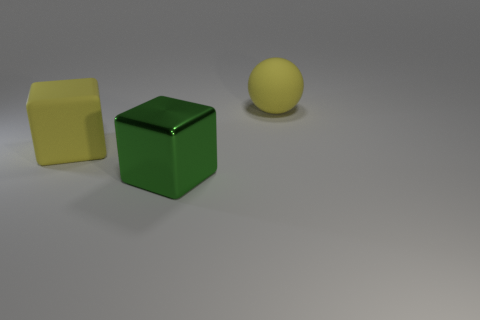What is the large yellow thing behind the big yellow object that is in front of the large yellow rubber sphere made of? The object you are referring to appears to be a simple, cube-shaped block. While the image does not provide enough detail to ascertain the exact material with certainty, the block's appearance is consistent with objects that are typically made of plastic or wood. Given that blocks are often used as children's toys, plastic would be a common material due to its durability and light weight. 